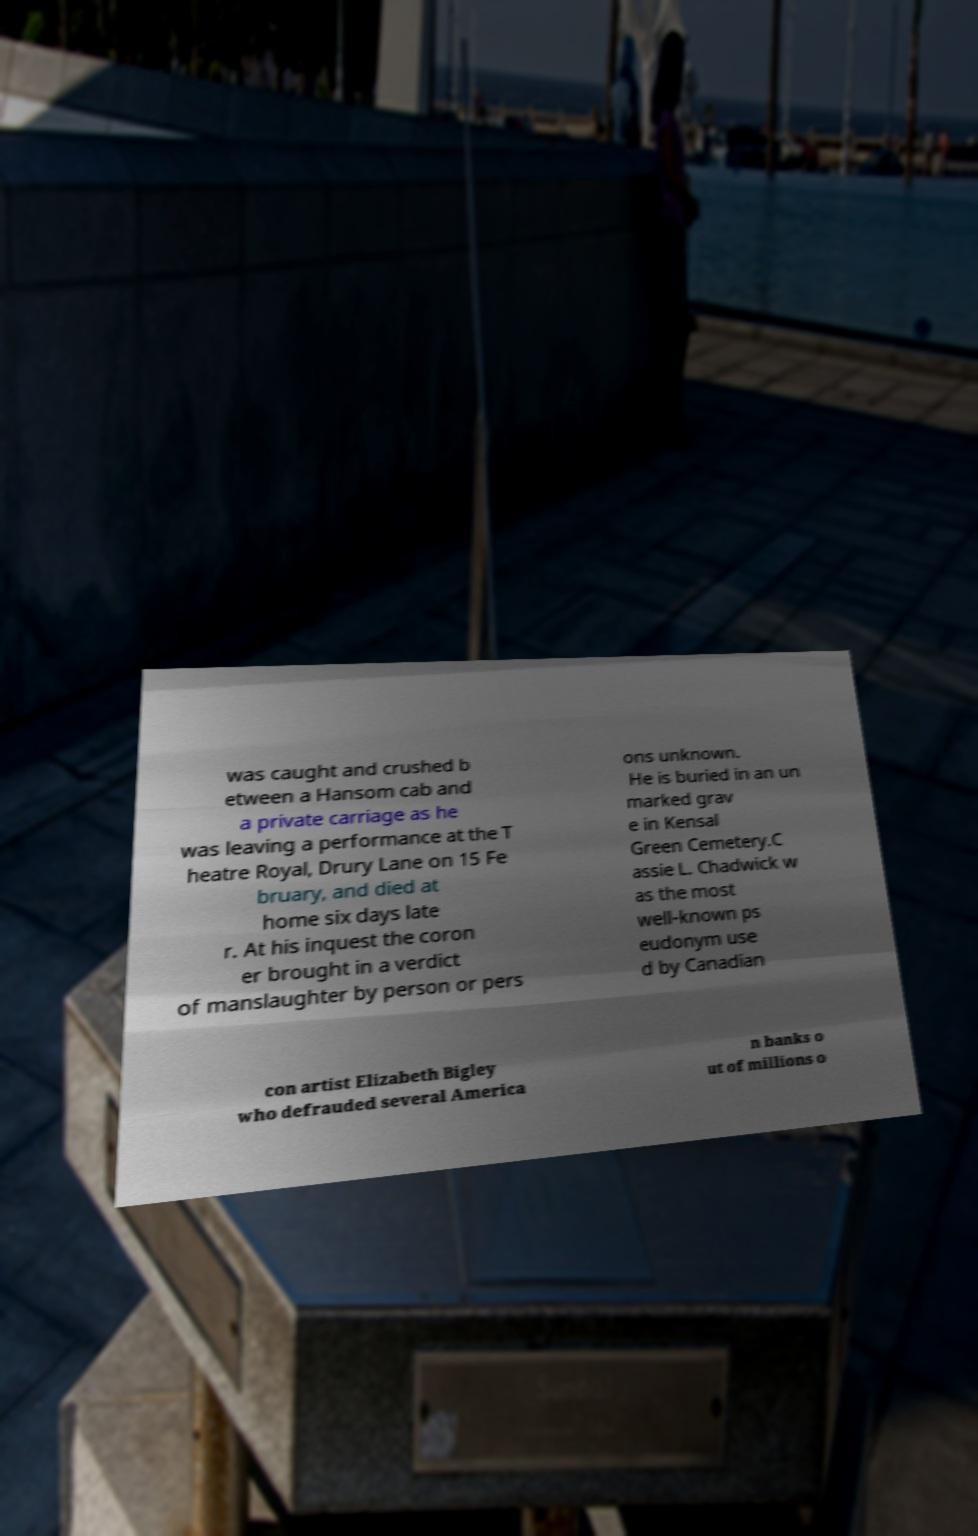I need the written content from this picture converted into text. Can you do that? was caught and crushed b etween a Hansom cab and a private carriage as he was leaving a performance at the T heatre Royal, Drury Lane on 15 Fe bruary, and died at home six days late r. At his inquest the coron er brought in a verdict of manslaughter by person or pers ons unknown. He is buried in an un marked grav e in Kensal Green Cemetery.C assie L. Chadwick w as the most well-known ps eudonym use d by Canadian con artist Elizabeth Bigley who defrauded several America n banks o ut of millions o 